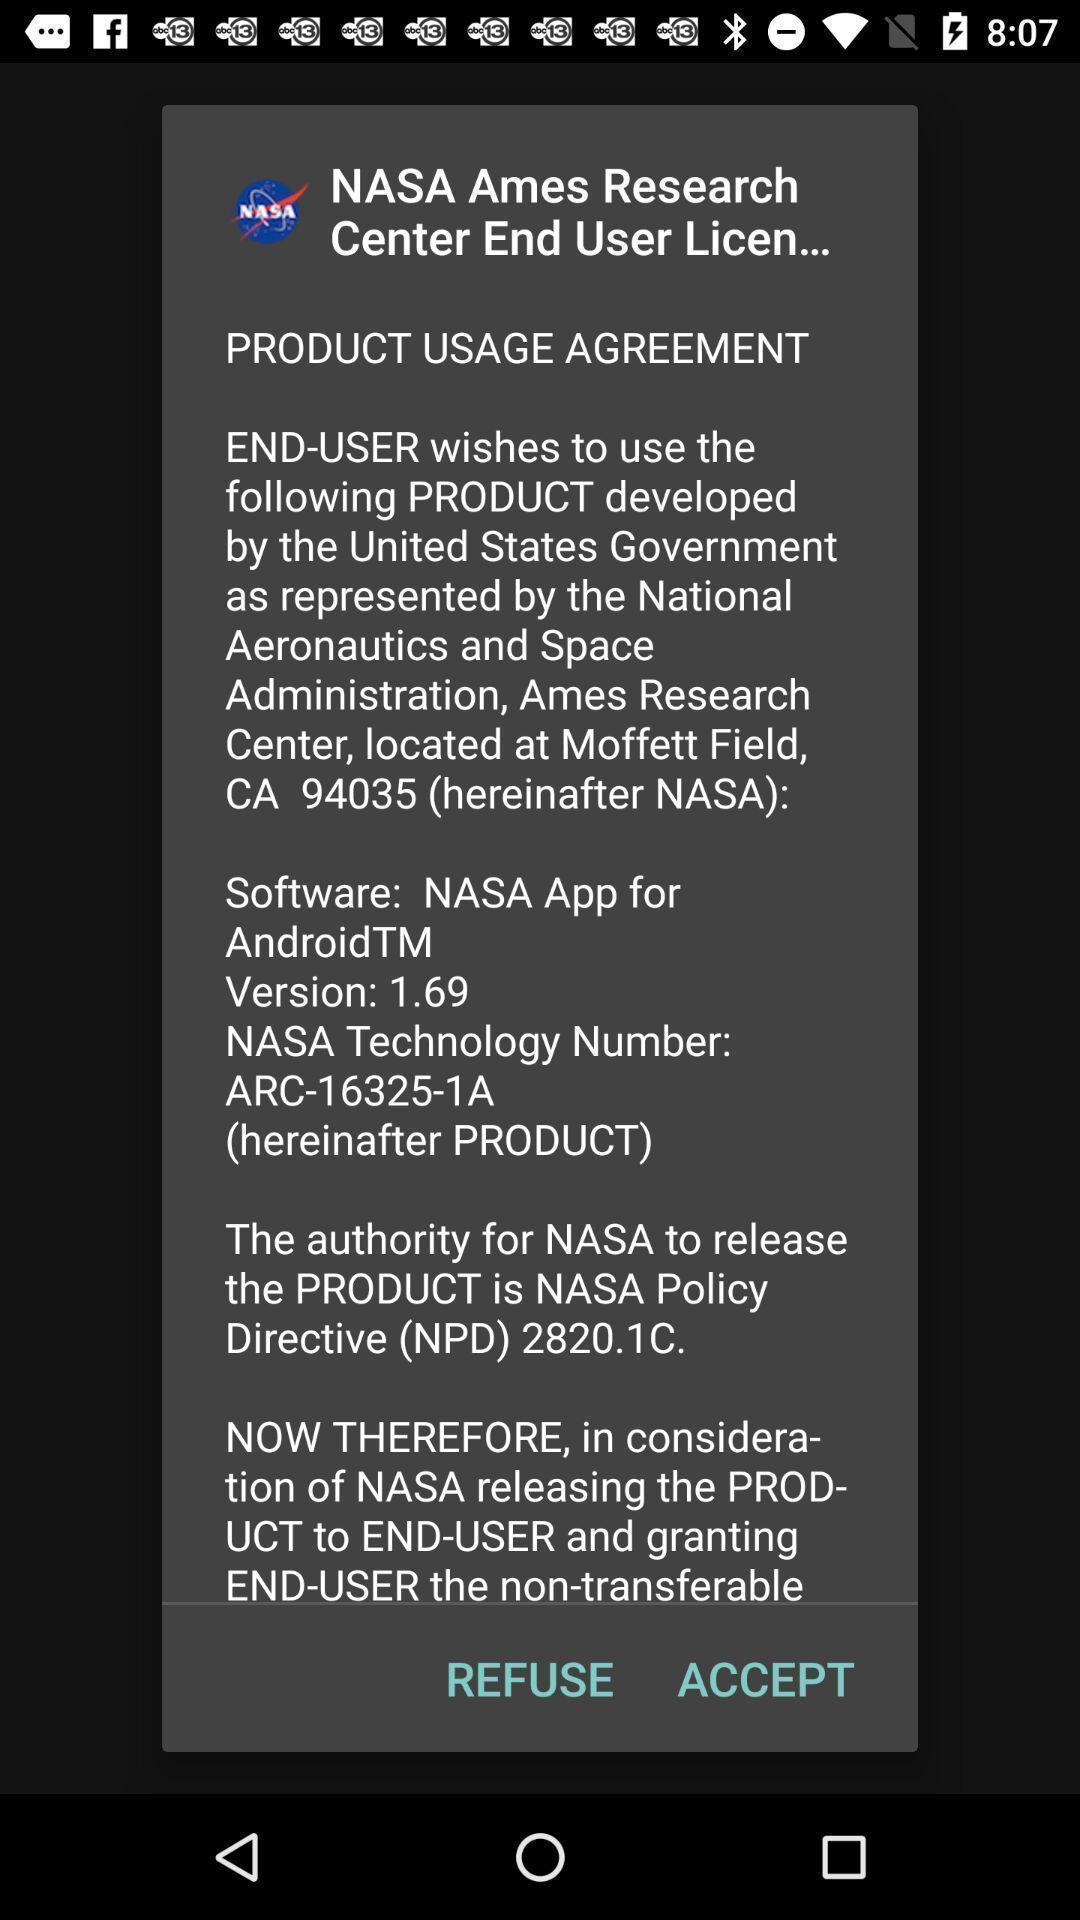Describe the visual elements of this screenshot. Pop-up showing options like refuse accept. 